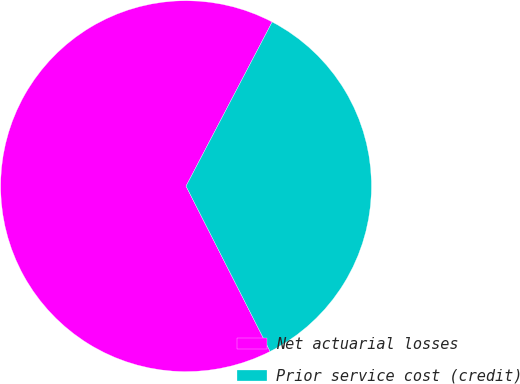<chart> <loc_0><loc_0><loc_500><loc_500><pie_chart><fcel>Net actuarial losses<fcel>Prior service cost (credit)<nl><fcel>65.18%<fcel>34.82%<nl></chart> 